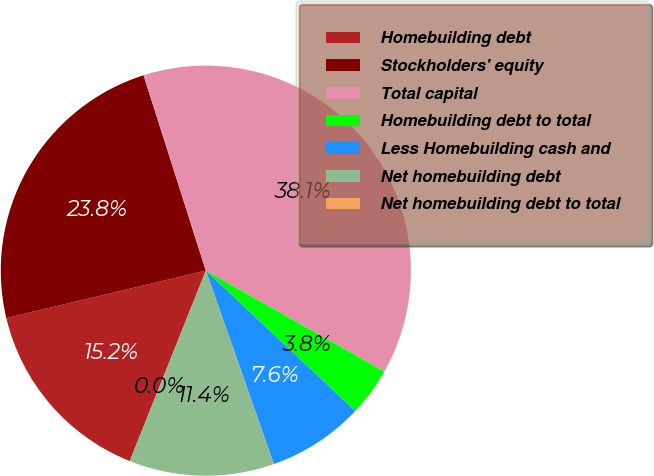Convert chart to OTSL. <chart><loc_0><loc_0><loc_500><loc_500><pie_chart><fcel>Homebuilding debt<fcel>Stockholders' equity<fcel>Total capital<fcel>Homebuilding debt to total<fcel>Less Homebuilding cash and<fcel>Net homebuilding debt<fcel>Net homebuilding debt to total<nl><fcel>15.24%<fcel>23.8%<fcel>38.1%<fcel>3.81%<fcel>7.62%<fcel>11.43%<fcel>0.0%<nl></chart> 